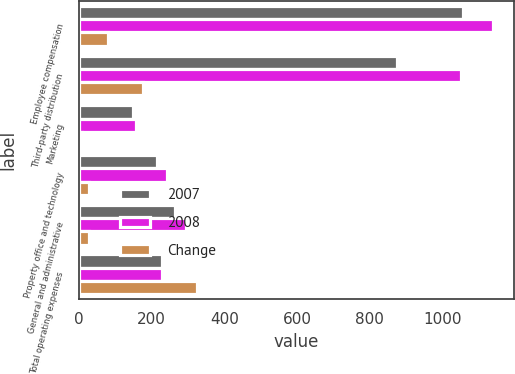Convert chart to OTSL. <chart><loc_0><loc_0><loc_500><loc_500><stacked_bar_chart><ecel><fcel>Employee compensation<fcel>Third-party distribution<fcel>Marketing<fcel>Property office and technology<fcel>General and administrative<fcel>Total operating expenses<nl><fcel>2007<fcel>1055.8<fcel>875.5<fcel>148.2<fcel>214.3<fcel>266<fcel>228.4<nl><fcel>2008<fcel>1137.6<fcel>1051.1<fcel>157.6<fcel>242.5<fcel>295.8<fcel>228.4<nl><fcel>Change<fcel>81.8<fcel>175.6<fcel>9.4<fcel>28.2<fcel>29.8<fcel>324.8<nl></chart> 